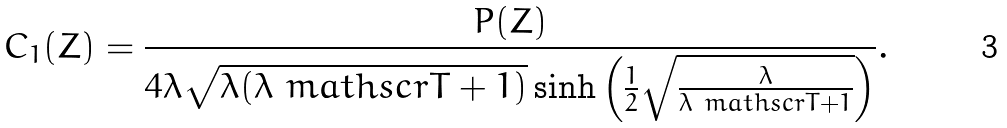Convert formula to latex. <formula><loc_0><loc_0><loc_500><loc_500>C _ { 1 } ( Z ) = \frac { P ( Z ) } { 4 \lambda \sqrt { \lambda ( \lambda \ m a t h s c r { T } + 1 ) } \sinh \left ( \frac { 1 } { 2 } \sqrt { \frac { \lambda } { \lambda \ m a t h s c r { T } + 1 } } \right ) } .</formula> 